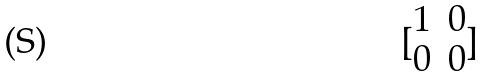Convert formula to latex. <formula><loc_0><loc_0><loc_500><loc_500>[ \begin{matrix} 1 & 0 \\ 0 & 0 \end{matrix} ]</formula> 